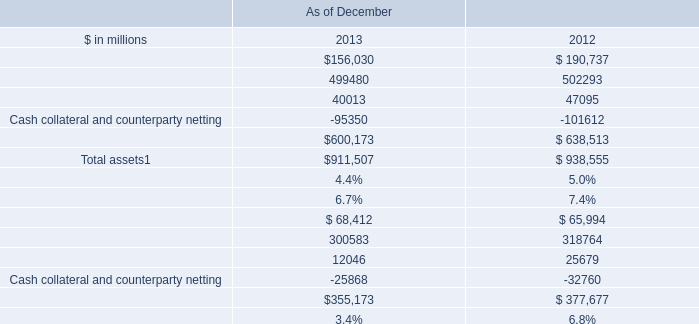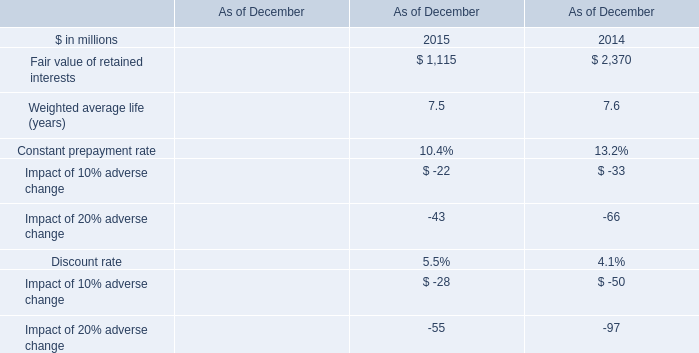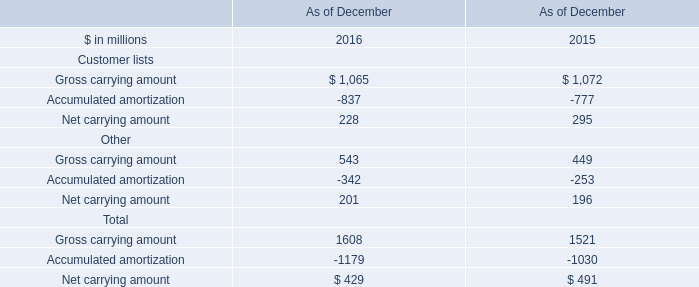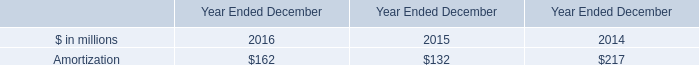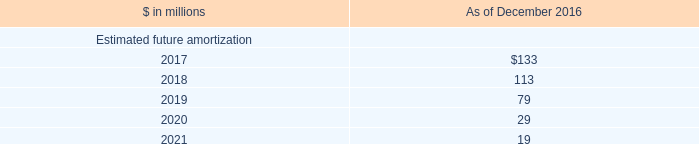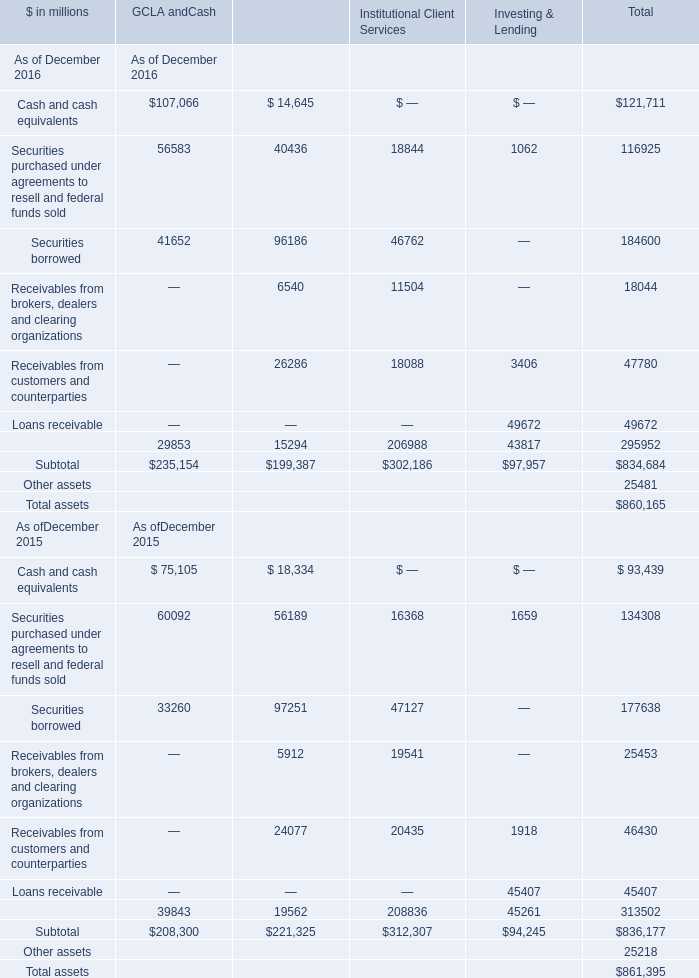What's the average of Cash collateral and counterparty netting of As of December 2013, and Financial instruments owned, at fair value of Institutional Client Services ? 
Computations: ((95350.0 + 206988.0) / 2)
Answer: 151169.0. 